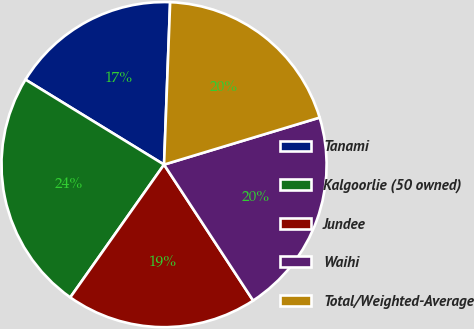<chart> <loc_0><loc_0><loc_500><loc_500><pie_chart><fcel>Tanami<fcel>Kalgoorlie (50 owned)<fcel>Jundee<fcel>Waihi<fcel>Total/Weighted-Average<nl><fcel>16.84%<fcel>23.97%<fcel>19.02%<fcel>20.44%<fcel>19.73%<nl></chart> 